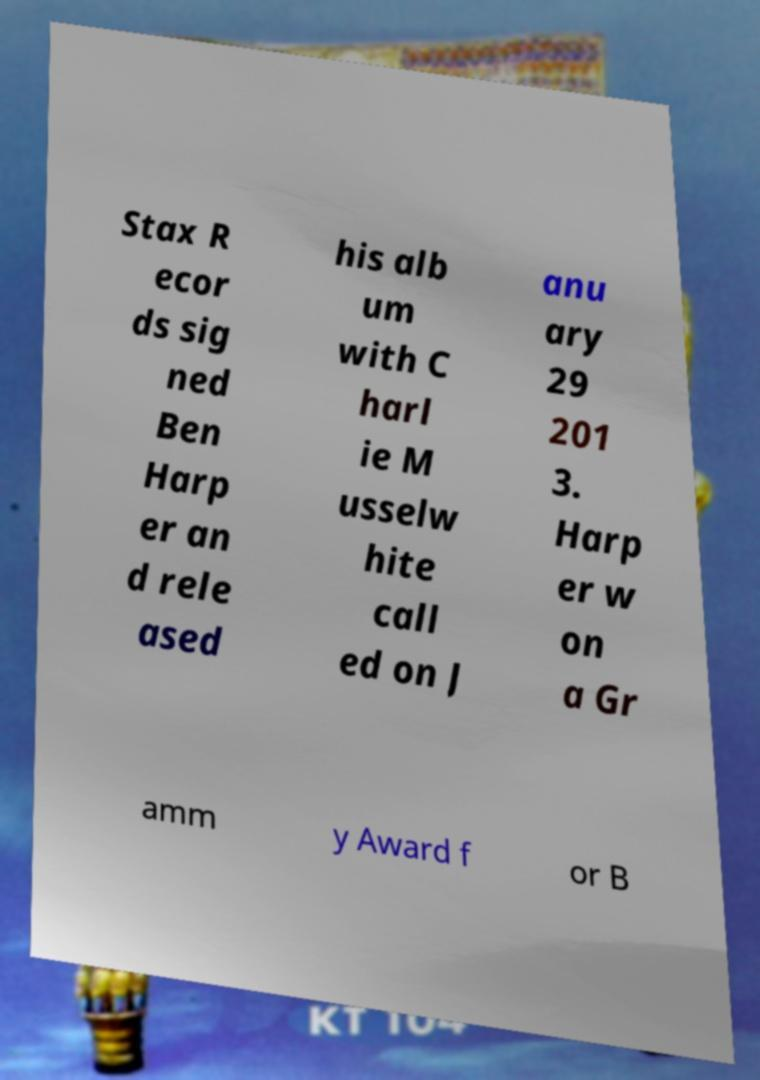I need the written content from this picture converted into text. Can you do that? Stax R ecor ds sig ned Ben Harp er an d rele ased his alb um with C harl ie M usselw hite call ed on J anu ary 29 201 3. Harp er w on a Gr amm y Award f or B 